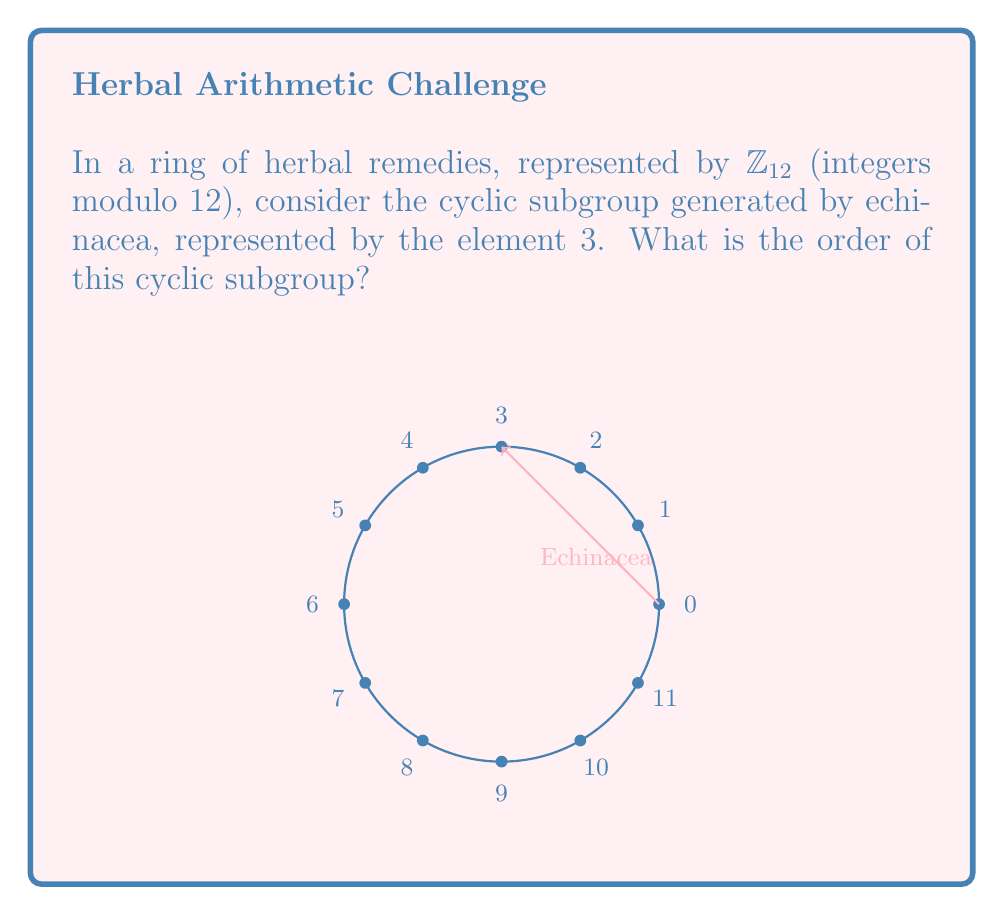Can you solve this math problem? To find the order of the cyclic subgroup generated by 3 in $\mathbb{Z}_{12}$, we need to determine the smallest positive integer $n$ such that $3n \equiv 0 \pmod{12}$. Let's proceed step-by-step:

1) First, let's list the multiples of 3 in $\mathbb{Z}_{12}$:
   $3 \cdot 1 \equiv 3 \pmod{12}$
   $3 \cdot 2 \equiv 6 \pmod{12}$
   $3 \cdot 3 \equiv 9 \pmod{12}$
   $3 \cdot 4 \equiv 0 \pmod{12}$

2) We see that $3 \cdot 4 \equiv 0 \pmod{12}$, and this is the smallest positive integer that gives us 0.

3) Therefore, the order of the subgroup is 4.

4) We can verify this by checking that the subgroup indeed consists of 4 elements:
   $\{0, 3, 6, 9\}$

5) In terms of herbal remedies, this could represent a cycle of echinacea usage: no dose (0), standard dose (3), double dose (6), and triple dose (9), before returning to no dose (0).

The order of a subgroup must always divide the order of the group. Indeed, $4$ divides $12$, confirming our result.
Answer: 4 